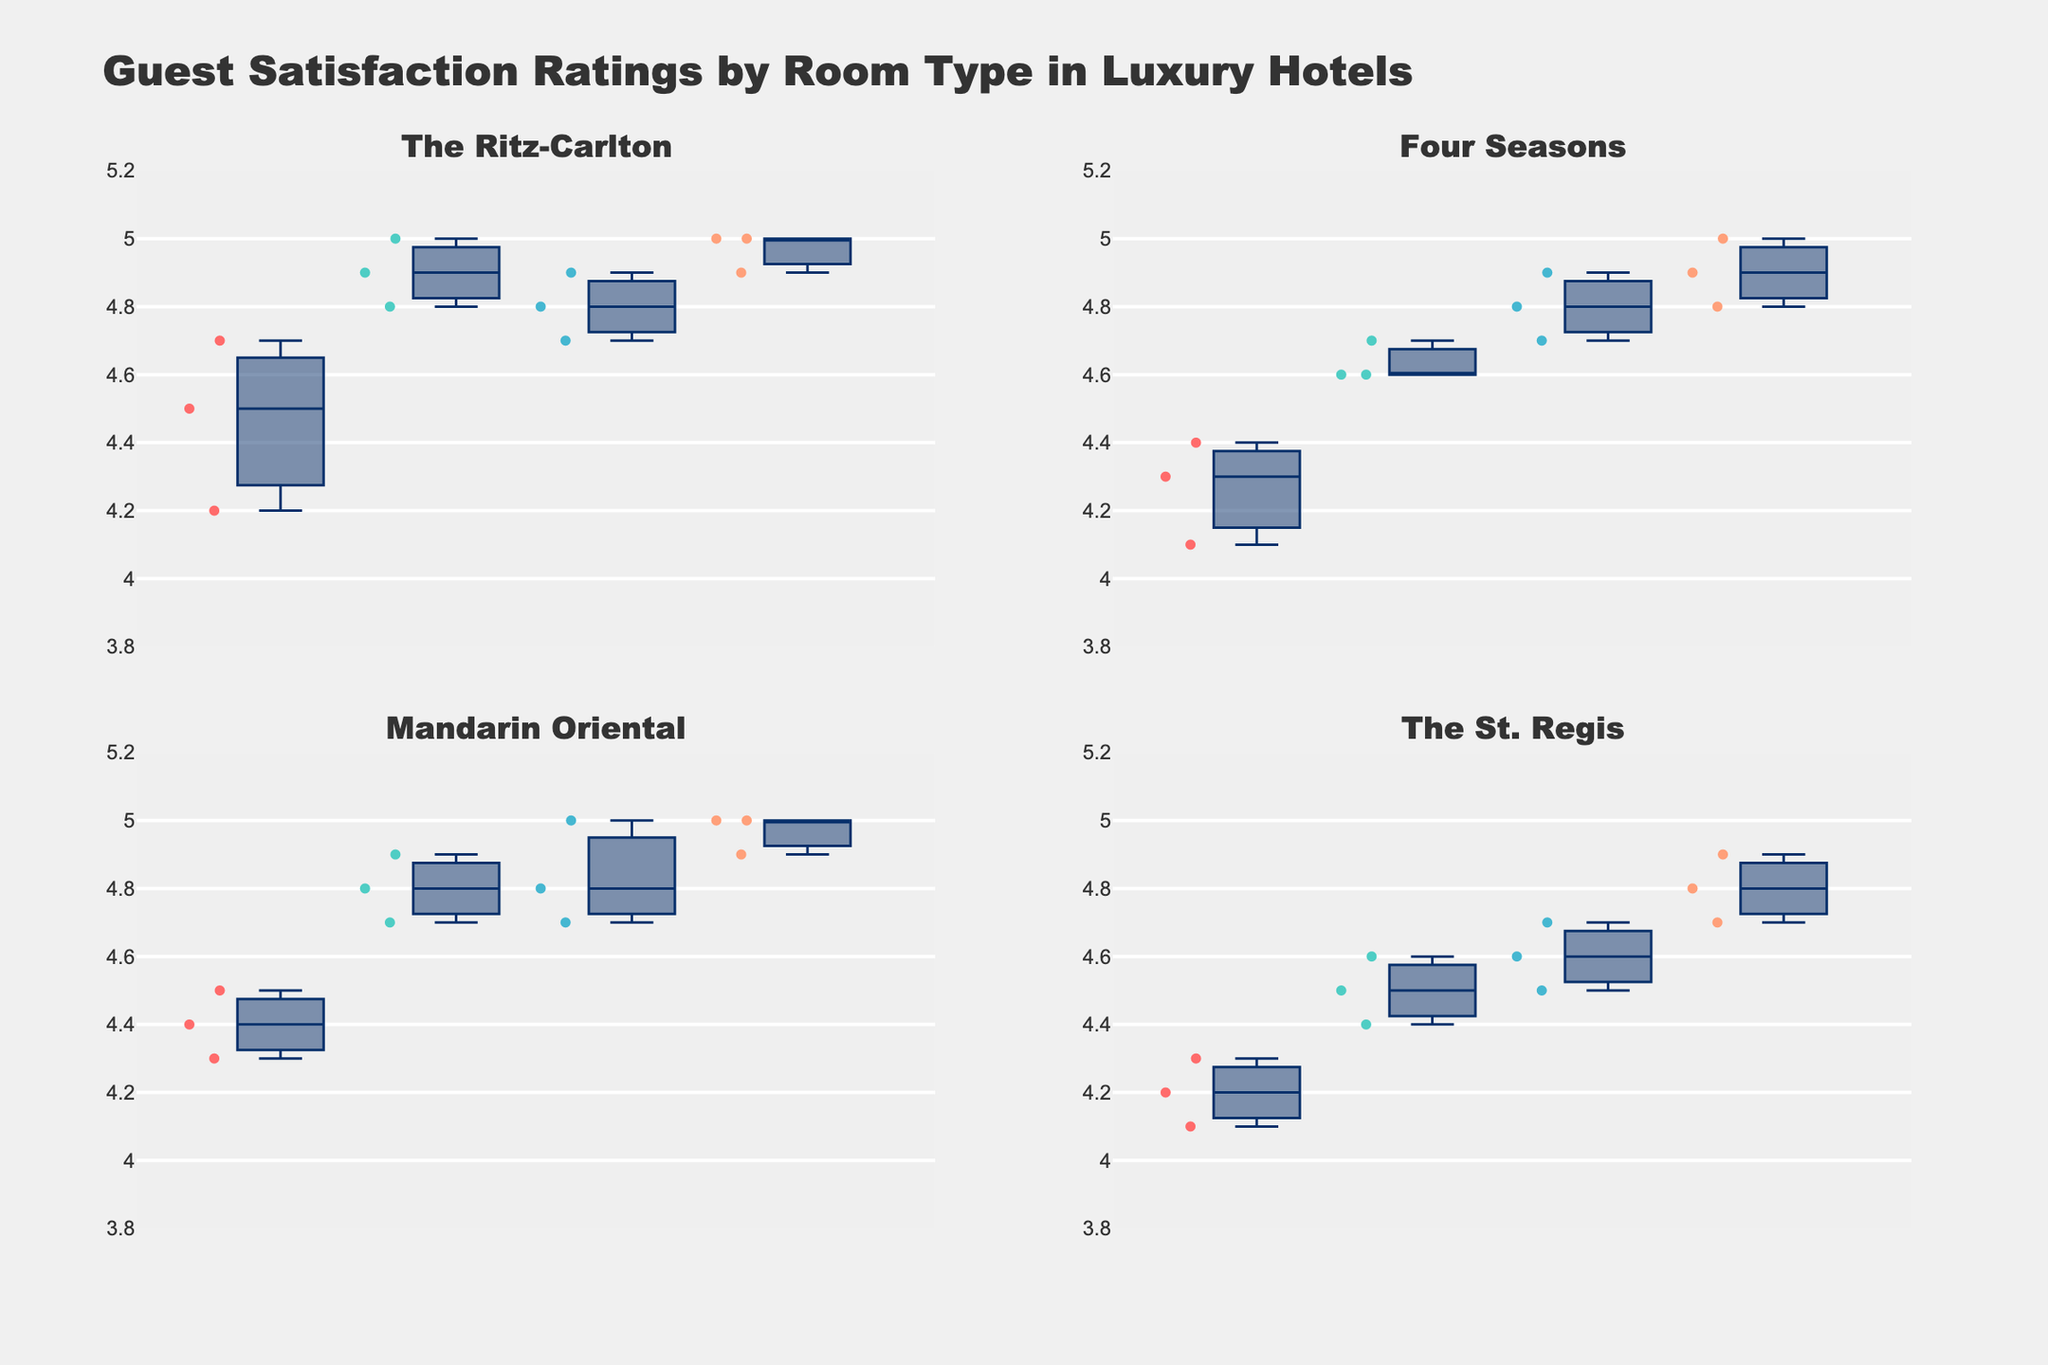What is the title of the plot? The title is located at the top center of the figure above the subplots. It is often in a larger and bolder font compared to other text in the plot.
Answer: Guest Satisfaction Ratings by Room Type in Luxury Hotels Which room type has the highest median rating at The Ritz-Carlton? To find the highest median, look at the middle line within each box plot for The Ritz-Carlton's subplots. The box representing the distribution that has the highest middle line is the answer.
Answer: Presidential What is the range of guest ratings for the Standard room type at Mandarin Oriental? The range is determined by the difference between the maximum and minimum points shown by the whiskers of the box plot. For the Standard room type at Mandarin Oriental, check the top and bottom of the box plot to note the highest and lowest data points.
Answer: 4.4 - 4.5 Which hotel has the most variability in guest ratings for the Deluxe room type? Variability can be observed by the interquartile range (IQR), which is the width of the box in the box plot. Look for the Deluxe room type box plot in each hotel's subplot and compare the widths of the boxes.
Answer: The St. Regis How does the median guest rating for Suites at Four Seasons compare to the Ritz-Carlton? Compare the middle line within the Suite box plots for Four Seasons and The Ritz-Carlton. The line that appears higher indicates a higher median rating.
Answer: Four Seasons is slightly higher What can you say about the distribution of guest ratings for Presidential rooms across all hotels? Observe the positions and spreads of the box plots for Presidential rooms in all subplots, looking for consistency or variability in central positioning and spread.
Answer: Generally high and tightly clustered around 5.0 In which hotel does the Deluxe room type show the least spread (variability) in guest ratings? The spread is apparent by looking at the width of the box and the length of the whiskers in the Deluxe room type box plots across all hotels. The narrower the box and shorter the whiskers, the less variability.
Answer: Four Seasons Which room type at The St. Regis has the lowest median rating? Look at the central lines in the box plots for all room types at The St. Regis. The box with the line closest to the lower part of the y-axis represents the lowest median rating.
Answer: Standard Compare the median ratings of Deluxe room types at The Ritz-Carlton and Mandarin Oriental. Find the middle lines in the Deluxe room type box plots for both The Ritz-Carlton and Mandarin Oriental and compare their heights.
Answer: Mandarin Oriental is slightly higher 